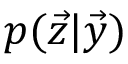Convert formula to latex. <formula><loc_0><loc_0><loc_500><loc_500>p ( \vec { z } | \vec { y } )</formula> 